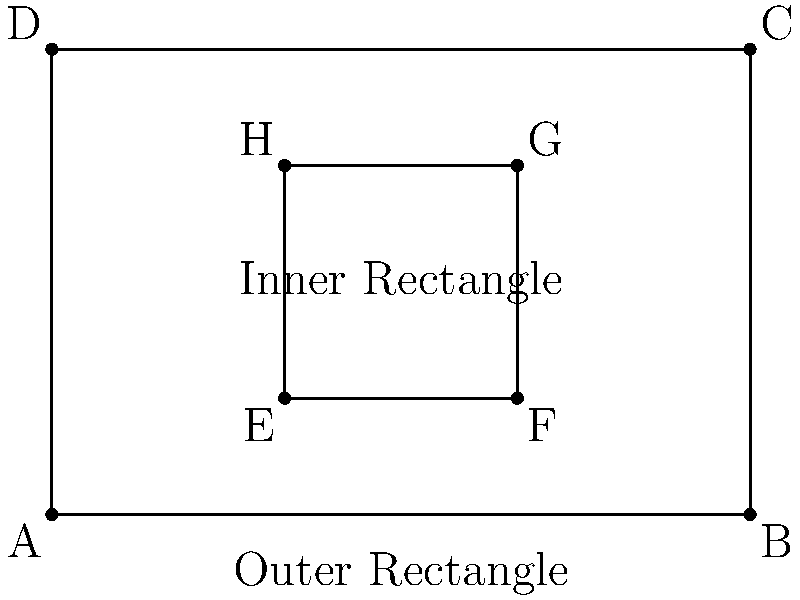As a calligrapher designing a pottery piece, you've created a pattern consisting of two rectangles: an outer rectangle ABCD and an inner rectangle EFGH. The coordinates of the vertices are A(0,0), B(6,0), C(6,4), D(0,4), E(2,1), F(4,1), G(4,3), and H(2,3). Calculate the coordinates of the centroid of the entire design (the area between the two rectangles). To find the centroid of the shape, we need to follow these steps:

1) First, calculate the area of each part:
   Area of outer rectangle = 6 * 4 = 24
   Area of inner rectangle = 2 * 2 = 4
   Area of the shape = 24 - 4 = 20

2) Find the centroid of each rectangle:
   Outer rectangle centroid: (3, 2)
   Inner rectangle centroid: (3, 2)

3) Use the formula for the centroid of a composite shape:
   $x = \frac{\sum (A_i * x_i)}{\sum A_i}$
   $y = \frac{\sum (A_i * y_i)}{\sum A_i}$

   Where $A_i$ is the area of each part, and $(x_i, y_i)$ is the centroid of each part.

4) Calculate:
   $x = \frac{24 * 3 - 4 * 3}{20} = \frac{60}{20} = 3$
   $y = \frac{24 * 2 - 4 * 2}{20} = \frac{40}{20} = 2$

Therefore, the centroid of the entire design is at (3, 2).
Answer: (3, 2) 